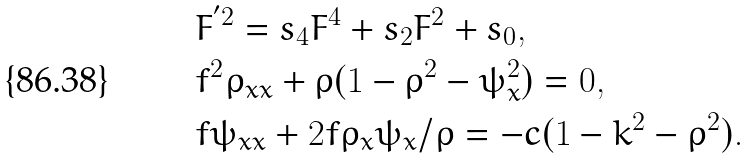Convert formula to latex. <formula><loc_0><loc_0><loc_500><loc_500>& F ^ { ^ { \prime } 2 } = s _ { 4 } F ^ { 4 } + s _ { 2 } F ^ { 2 } + s _ { 0 } , \\ & f ^ { 2 } \rho _ { x x } + \rho ( 1 - \rho ^ { 2 } - \psi _ { x } ^ { 2 } ) = 0 , \\ & f \psi _ { x x } + 2 f \rho _ { x } \psi _ { x } / \rho = - c ( 1 - k ^ { 2 } - \rho ^ { 2 } ) .</formula> 